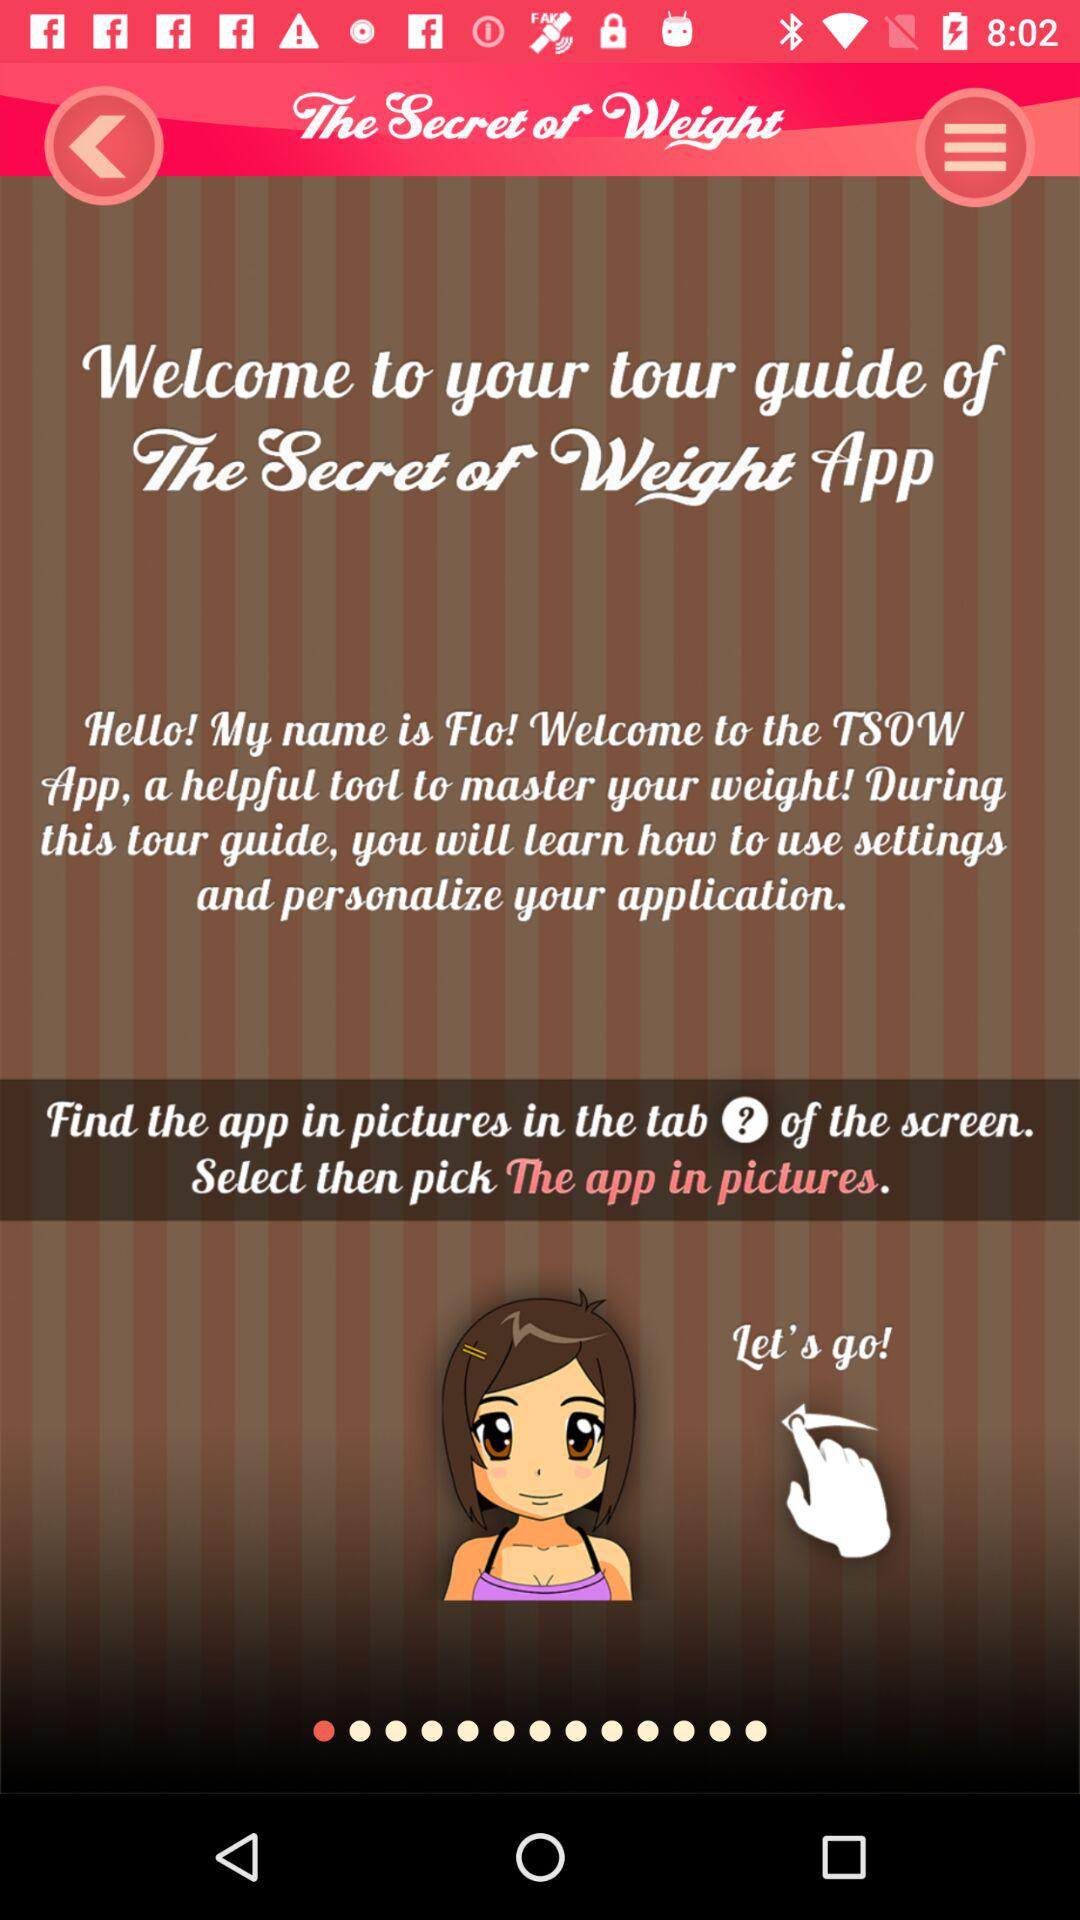What is the application name? The application name is "The Secret of Weight". 